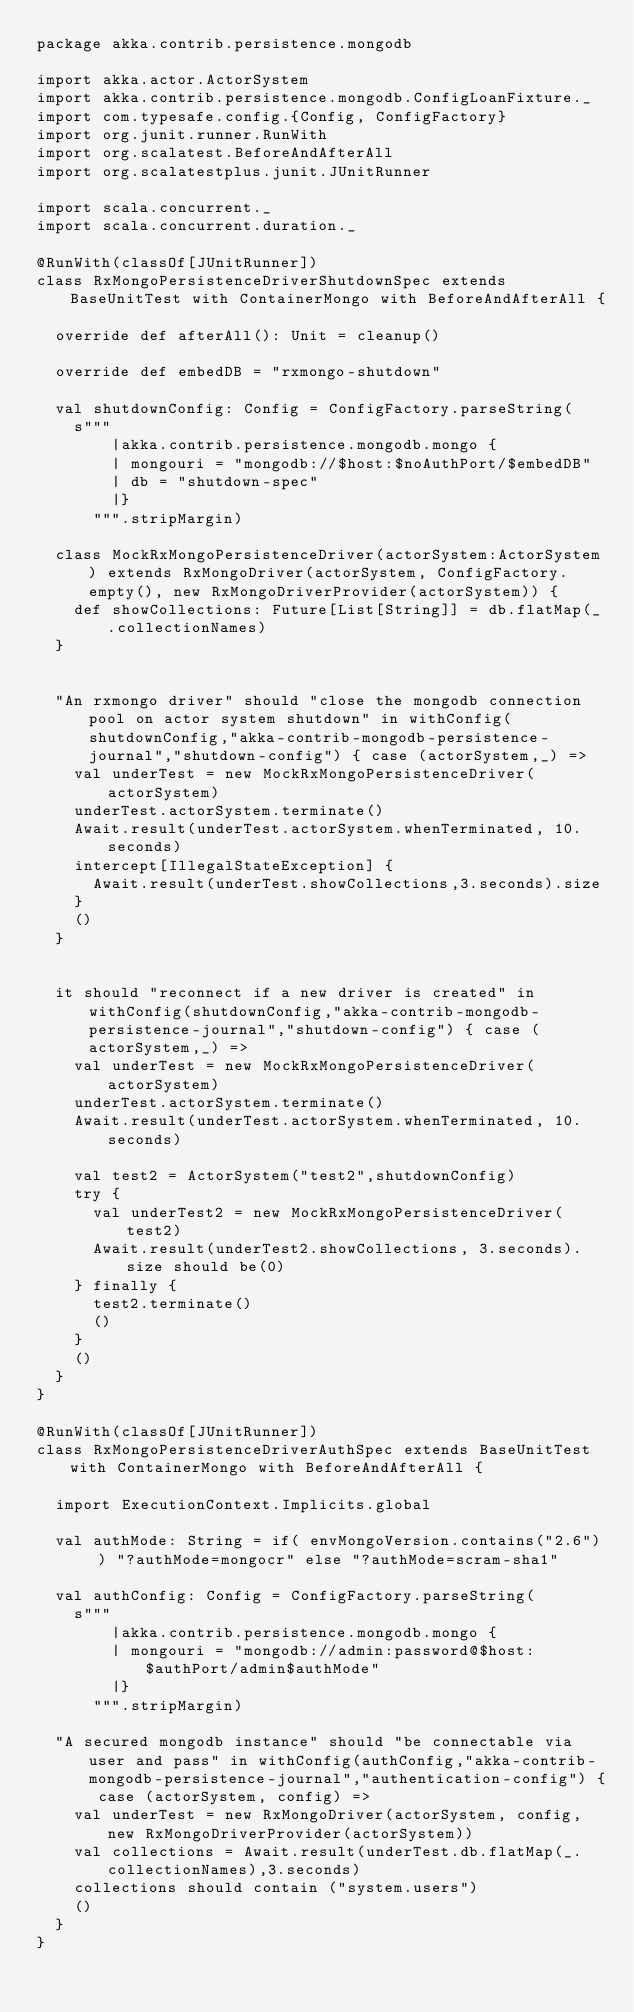<code> <loc_0><loc_0><loc_500><loc_500><_Scala_>package akka.contrib.persistence.mongodb

import akka.actor.ActorSystem
import akka.contrib.persistence.mongodb.ConfigLoanFixture._
import com.typesafe.config.{Config, ConfigFactory}
import org.junit.runner.RunWith
import org.scalatest.BeforeAndAfterAll
import org.scalatestplus.junit.JUnitRunner

import scala.concurrent._
import scala.concurrent.duration._

@RunWith(classOf[JUnitRunner])
class RxMongoPersistenceDriverShutdownSpec extends BaseUnitTest with ContainerMongo with BeforeAndAfterAll {

  override def afterAll(): Unit = cleanup()

  override def embedDB = "rxmongo-shutdown"

  val shutdownConfig: Config = ConfigFactory.parseString(
    s"""
        |akka.contrib.persistence.mongodb.mongo {
        | mongouri = "mongodb://$host:$noAuthPort/$embedDB"
        | db = "shutdown-spec"
        |}
      """.stripMargin)

  class MockRxMongoPersistenceDriver(actorSystem:ActorSystem) extends RxMongoDriver(actorSystem, ConfigFactory.empty(), new RxMongoDriverProvider(actorSystem)) {
    def showCollections: Future[List[String]] = db.flatMap(_.collectionNames)
  }


  "An rxmongo driver" should "close the mongodb connection pool on actor system shutdown" in withConfig(shutdownConfig,"akka-contrib-mongodb-persistence-journal","shutdown-config") { case (actorSystem,_) =>
    val underTest = new MockRxMongoPersistenceDriver(actorSystem)
    underTest.actorSystem.terminate()
    Await.result(underTest.actorSystem.whenTerminated, 10.seconds)
    intercept[IllegalStateException] {
      Await.result(underTest.showCollections,3.seconds).size
    }
    ()
  }


  it should "reconnect if a new driver is created" in withConfig(shutdownConfig,"akka-contrib-mongodb-persistence-journal","shutdown-config") { case (actorSystem,_) =>
    val underTest = new MockRxMongoPersistenceDriver(actorSystem)
    underTest.actorSystem.terminate()
    Await.result(underTest.actorSystem.whenTerminated, 10.seconds)

    val test2 = ActorSystem("test2",shutdownConfig)
    try {
      val underTest2 = new MockRxMongoPersistenceDriver(test2)
      Await.result(underTest2.showCollections, 3.seconds).size should be(0)
    } finally {
      test2.terminate()
      ()
    }
    ()
  }
}

@RunWith(classOf[JUnitRunner])
class RxMongoPersistenceDriverAuthSpec extends BaseUnitTest with ContainerMongo with BeforeAndAfterAll {

  import ExecutionContext.Implicits.global

  val authMode: String = if( envMongoVersion.contains("2.6") ) "?authMode=mongocr" else "?authMode=scram-sha1"

  val authConfig: Config = ConfigFactory.parseString(
    s"""
        |akka.contrib.persistence.mongodb.mongo {
        | mongouri = "mongodb://admin:password@$host:$authPort/admin$authMode"
        |}
      """.stripMargin)

  "A secured mongodb instance" should "be connectable via user and pass" in withConfig(authConfig,"akka-contrib-mongodb-persistence-journal","authentication-config") { case (actorSystem, config) =>
    val underTest = new RxMongoDriver(actorSystem, config, new RxMongoDriverProvider(actorSystem))
    val collections = Await.result(underTest.db.flatMap(_.collectionNames),3.seconds)
    collections should contain ("system.users")
    ()
  }
}</code> 